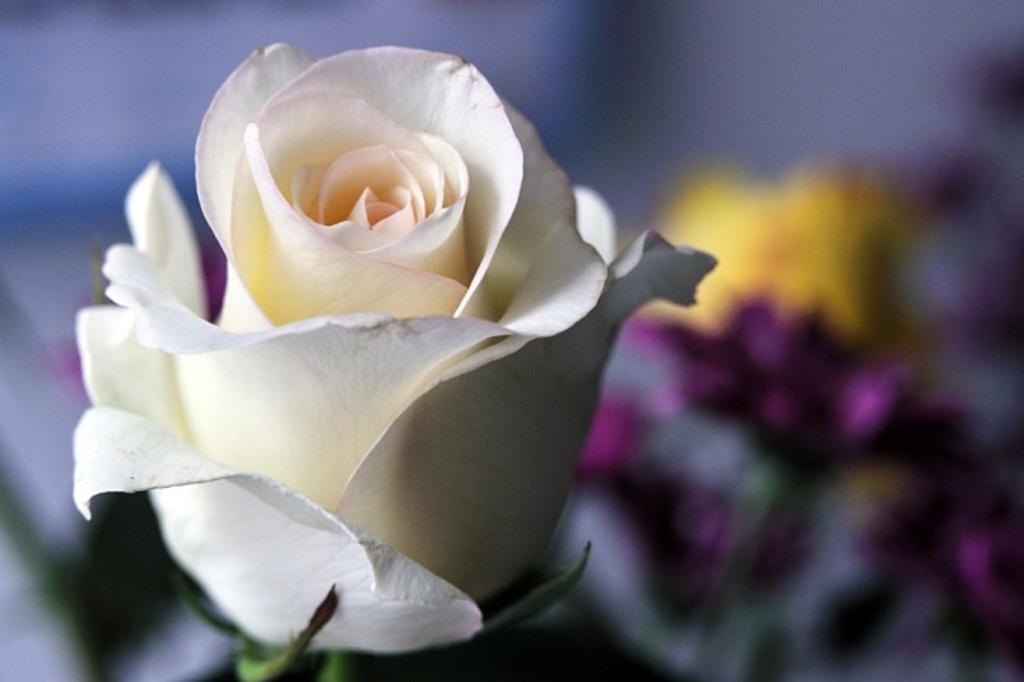What type of flower is in the image? There is a white color flower in the image. Can you describe the background of the image? The background of the image is blurred. Is there a lift visible in the image? No, there is no lift present in the image. What type of grass can be seen growing around the flower in the image? There is no grass visible in the image; only the flower and the blurred background are present. 